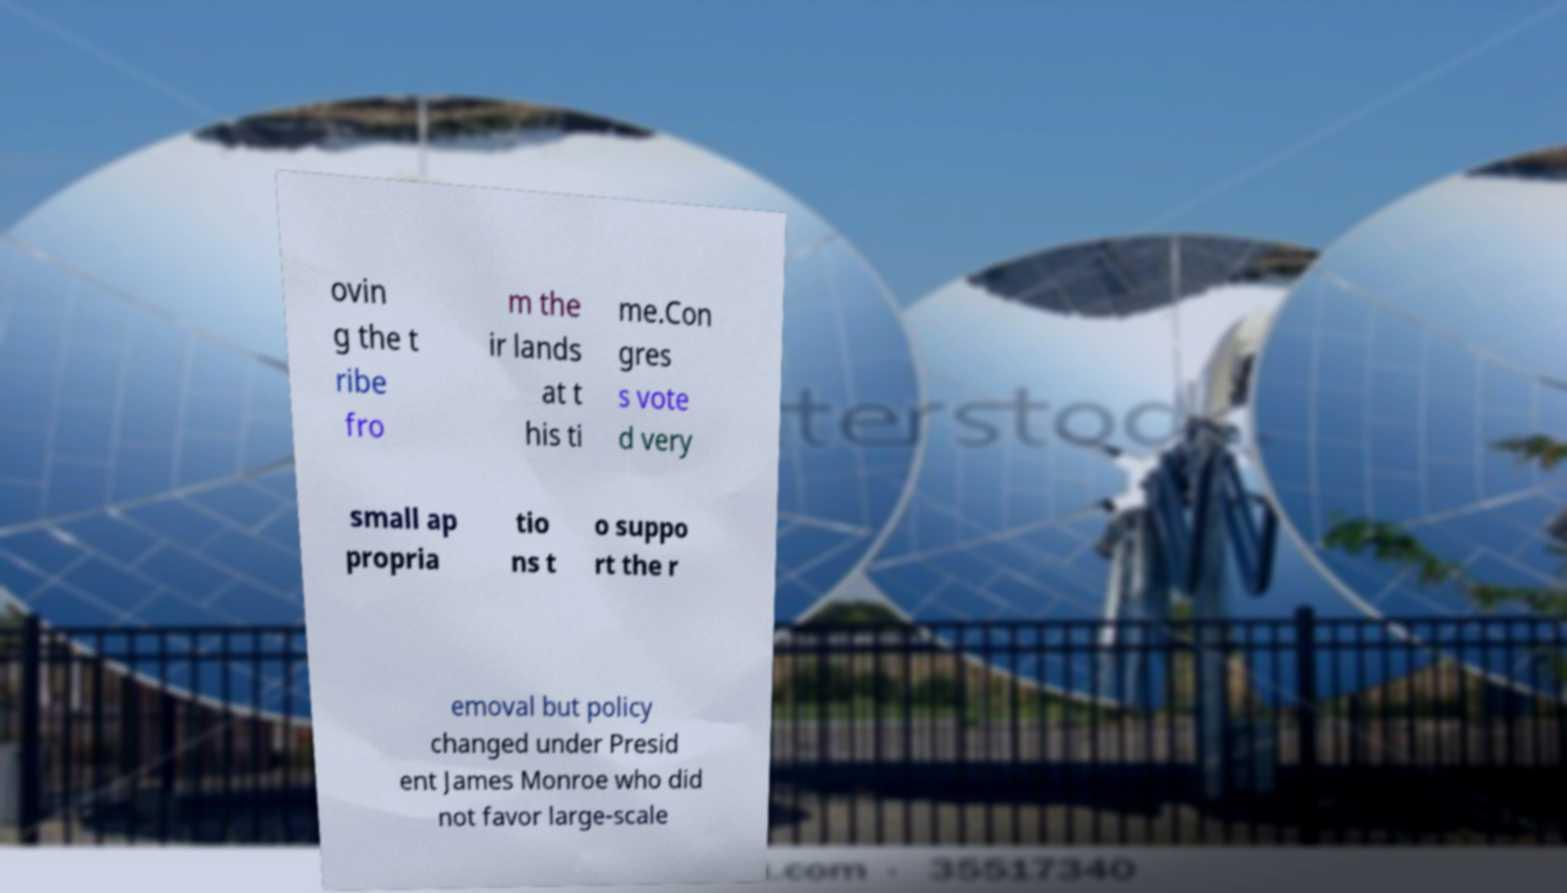For documentation purposes, I need the text within this image transcribed. Could you provide that? ovin g the t ribe fro m the ir lands at t his ti me.Con gres s vote d very small ap propria tio ns t o suppo rt the r emoval but policy changed under Presid ent James Monroe who did not favor large-scale 